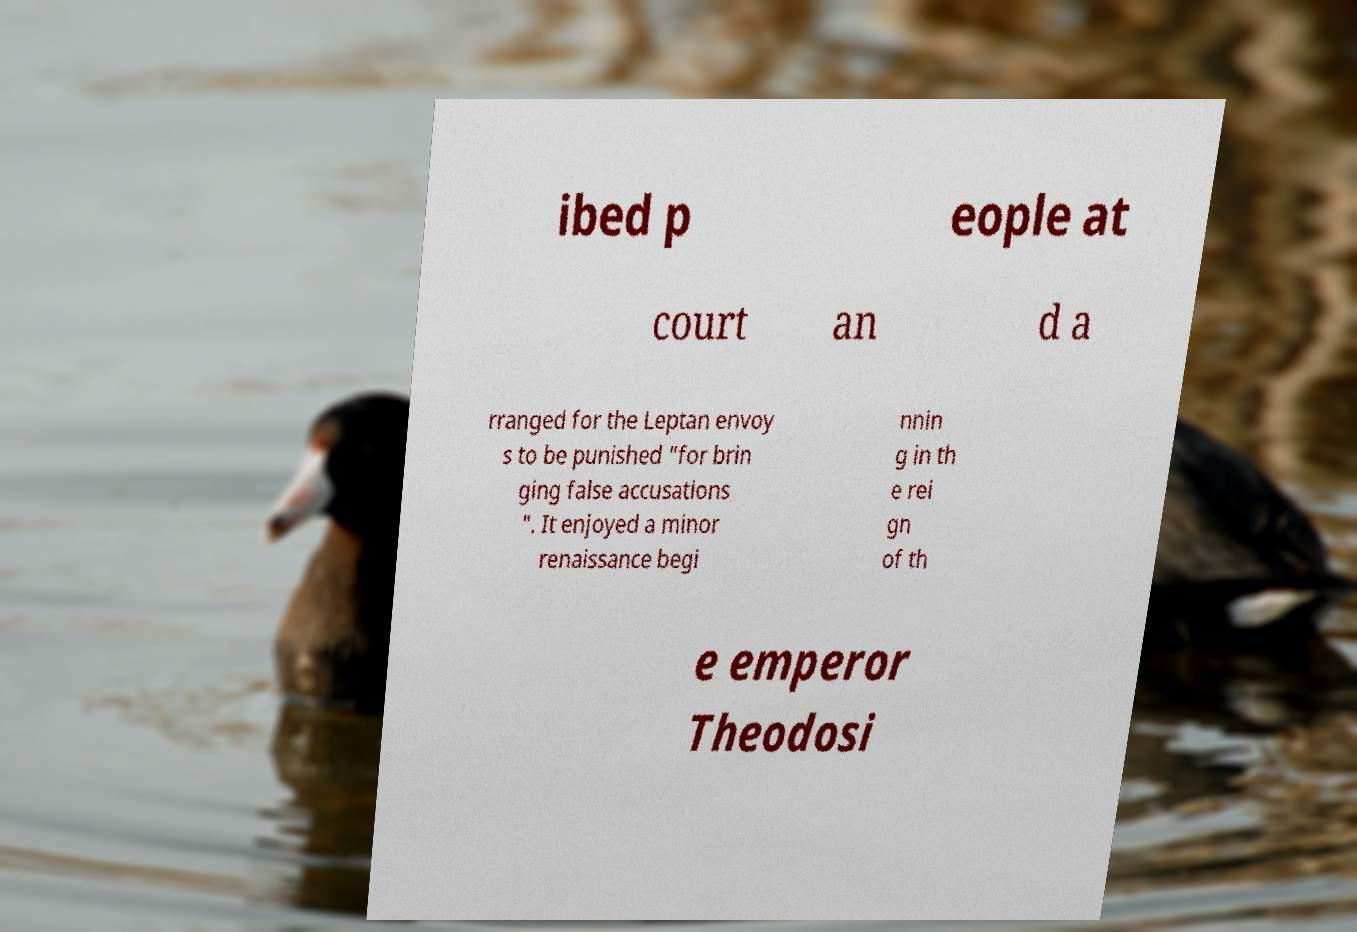Can you accurately transcribe the text from the provided image for me? ibed p eople at court an d a rranged for the Leptan envoy s to be punished "for brin ging false accusations ". It enjoyed a minor renaissance begi nnin g in th e rei gn of th e emperor Theodosi 